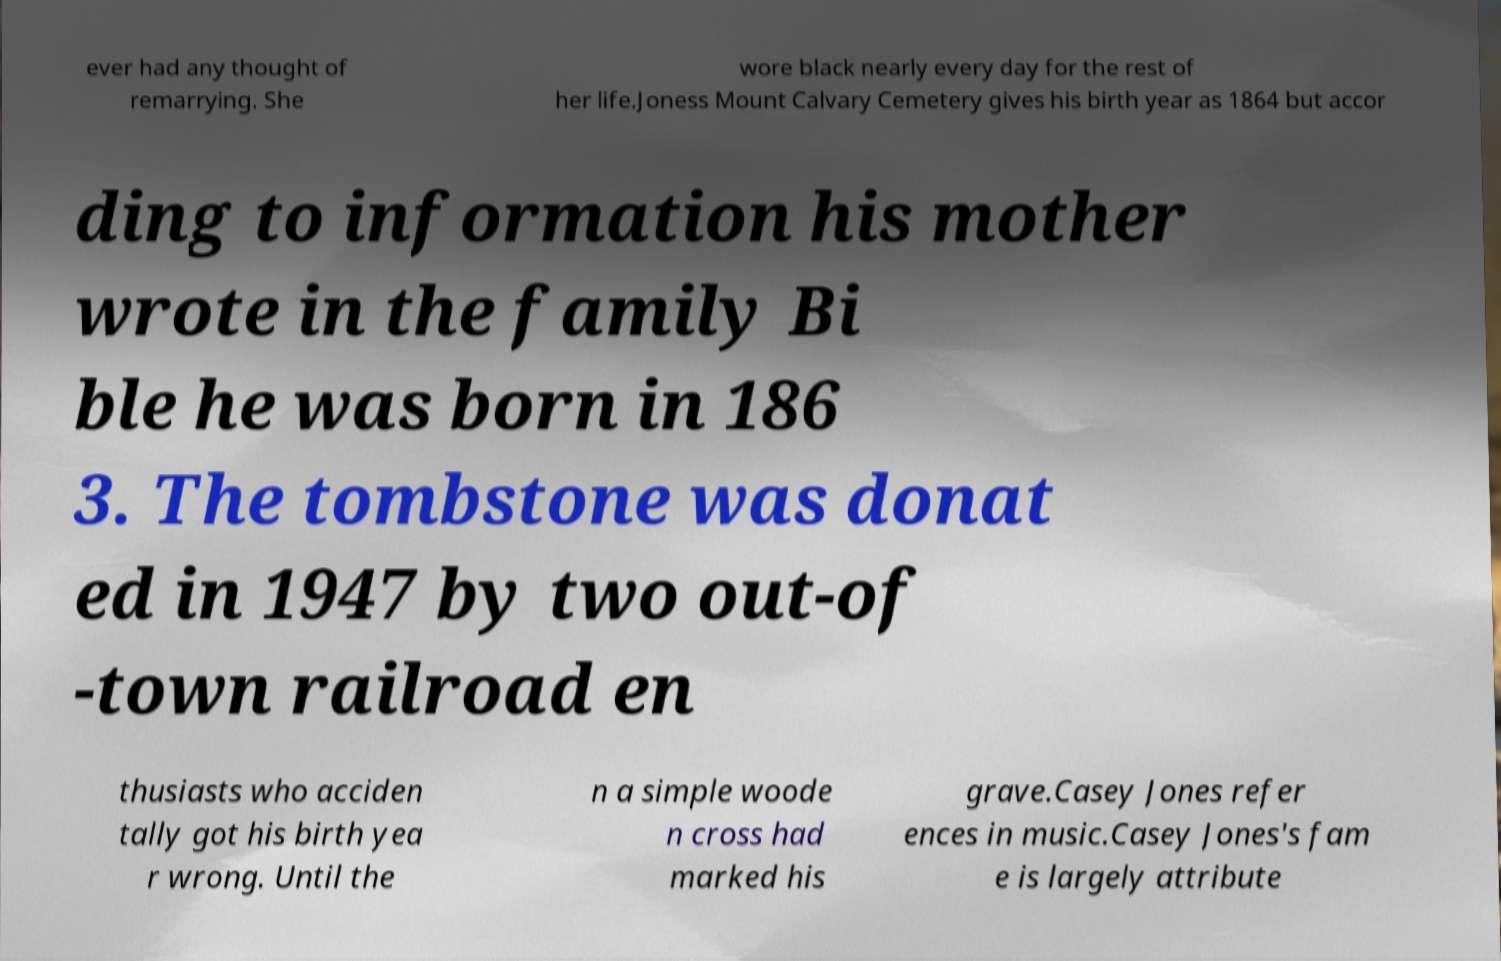Can you read and provide the text displayed in the image?This photo seems to have some interesting text. Can you extract and type it out for me? ever had any thought of remarrying. She wore black nearly every day for the rest of her life.Joness Mount Calvary Cemetery gives his birth year as 1864 but accor ding to information his mother wrote in the family Bi ble he was born in 186 3. The tombstone was donat ed in 1947 by two out-of -town railroad en thusiasts who acciden tally got his birth yea r wrong. Until the n a simple woode n cross had marked his grave.Casey Jones refer ences in music.Casey Jones's fam e is largely attribute 